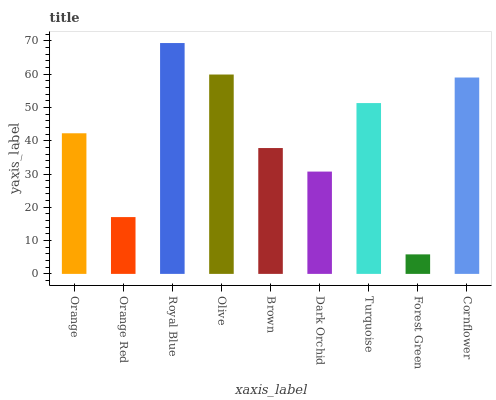Is Forest Green the minimum?
Answer yes or no. Yes. Is Royal Blue the maximum?
Answer yes or no. Yes. Is Orange Red the minimum?
Answer yes or no. No. Is Orange Red the maximum?
Answer yes or no. No. Is Orange greater than Orange Red?
Answer yes or no. Yes. Is Orange Red less than Orange?
Answer yes or no. Yes. Is Orange Red greater than Orange?
Answer yes or no. No. Is Orange less than Orange Red?
Answer yes or no. No. Is Orange the high median?
Answer yes or no. Yes. Is Orange the low median?
Answer yes or no. Yes. Is Brown the high median?
Answer yes or no. No. Is Brown the low median?
Answer yes or no. No. 